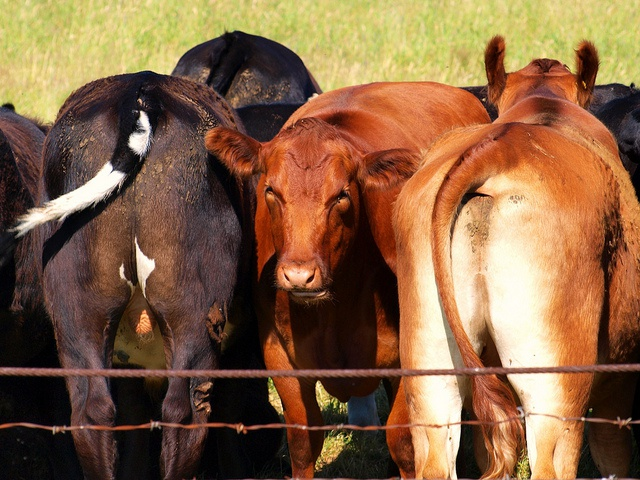Describe the objects in this image and their specific colors. I can see cow in khaki, orange, beige, brown, and red tones, cow in khaki, black, maroon, and brown tones, cow in khaki, black, maroon, brown, and red tones, cow in khaki, black, maroon, and brown tones, and cow in khaki, black, and gray tones in this image. 